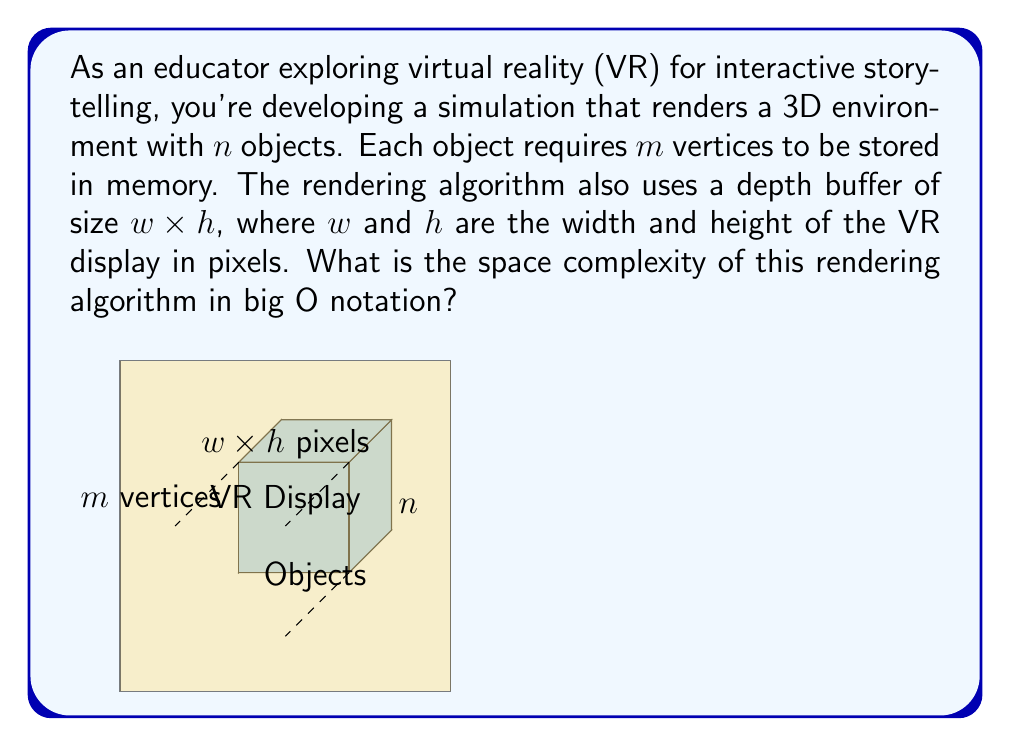Can you answer this question? To determine the space complexity, we need to consider the memory required for storing the objects and the depth buffer:

1. Object storage:
   - There are $n$ objects
   - Each object requires $m$ vertices
   - Total space for objects: $O(n \cdot m)$

2. Depth buffer:
   - The buffer size is $w \times h$
   - Total space for depth buffer: $O(w \cdot h)$

3. Combining the space requirements:
   - Total space = Space for objects + Space for depth buffer
   - $O(n \cdot m + w \cdot h)$

4. Simplifying the notation:
   - Since $n$, $m$, $w$, and $h$ are independent variables, we cannot combine them further
   - The final space complexity remains $O(n \cdot m + w \cdot h)$

This space complexity accounts for the memory needed to store the object data and the depth buffer used in the rendering process, which are the primary space-consuming components in a basic VR rendering algorithm.
Answer: $O(n \cdot m + w \cdot h)$ 